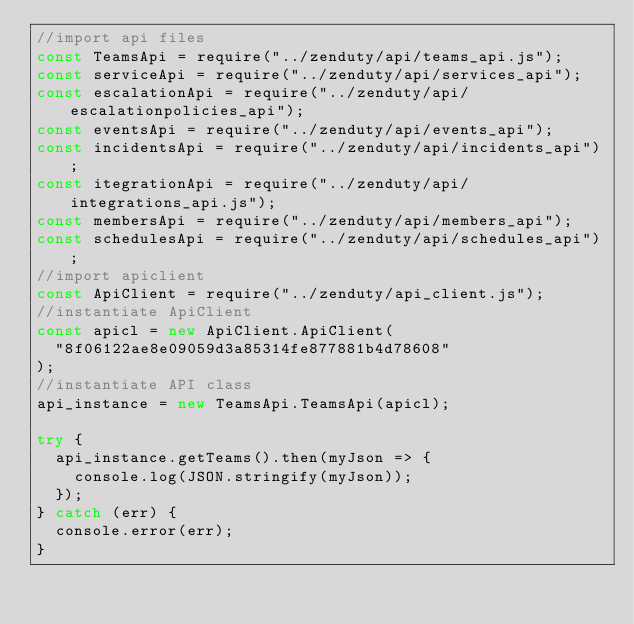<code> <loc_0><loc_0><loc_500><loc_500><_JavaScript_>//import api files
const TeamsApi = require("../zenduty/api/teams_api.js");
const serviceApi = require("../zenduty/api/services_api");
const escalationApi = require("../zenduty/api/escalationpolicies_api");
const eventsApi = require("../zenduty/api/events_api");
const incidentsApi = require("../zenduty/api/incidents_api");
const itegrationApi = require("../zenduty/api/integrations_api.js");
const membersApi = require("../zenduty/api/members_api");
const schedulesApi = require("../zenduty/api/schedules_api");
//import apiclient
const ApiClient = require("../zenduty/api_client.js");
//instantiate ApiClient
const apicl = new ApiClient.ApiClient(
  "8f06122ae8e09059d3a85314fe877881b4d78608"
);
//instantiate API class
api_instance = new TeamsApi.TeamsApi(apicl);

try {
  api_instance.getTeams().then(myJson => {
    console.log(JSON.stringify(myJson));
  });
} catch (err) {
  console.error(err);
}
</code> 